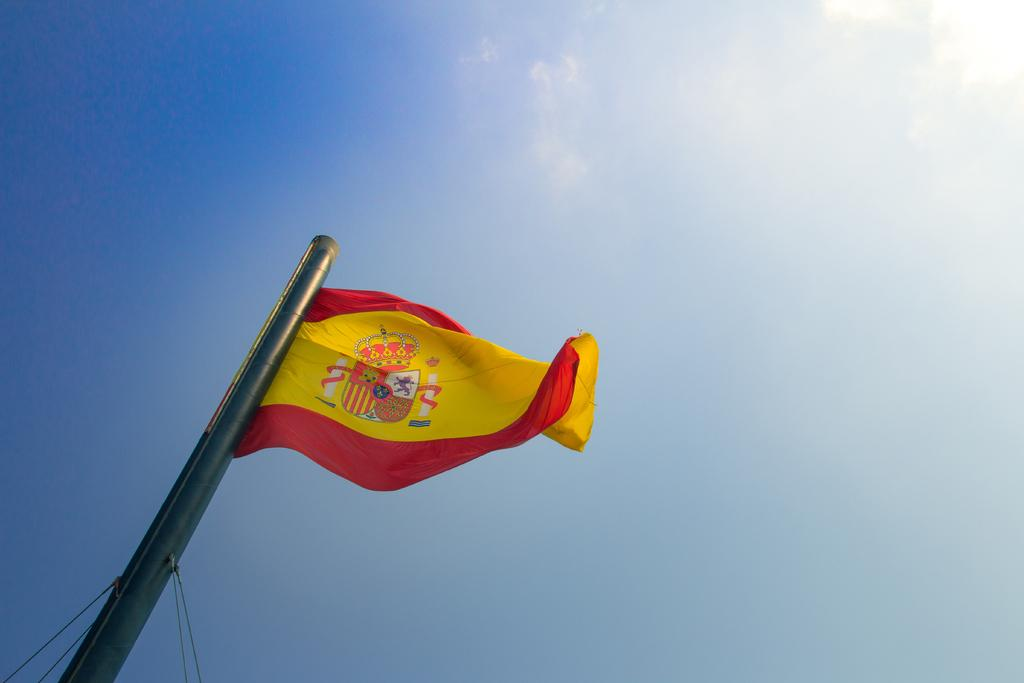What is located in the foreground of the image? There is a flag in the foreground of the image. How is the flag supported in the image? The flag is attached to a pole. What can be seen in the background of the image? The sky is visible in the background of the image. What type of natural formation can be observed in the sky? Clouds are present in the sky. What type of bird can be seen talking to the flag in the image? There is no bird present in the image, and the flag cannot talk. 